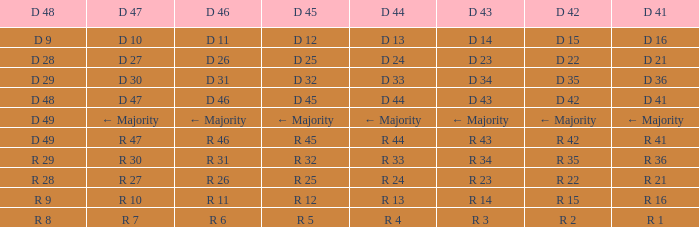Identify the d 44 when it possesses a d 46 of d 31 D 33. 